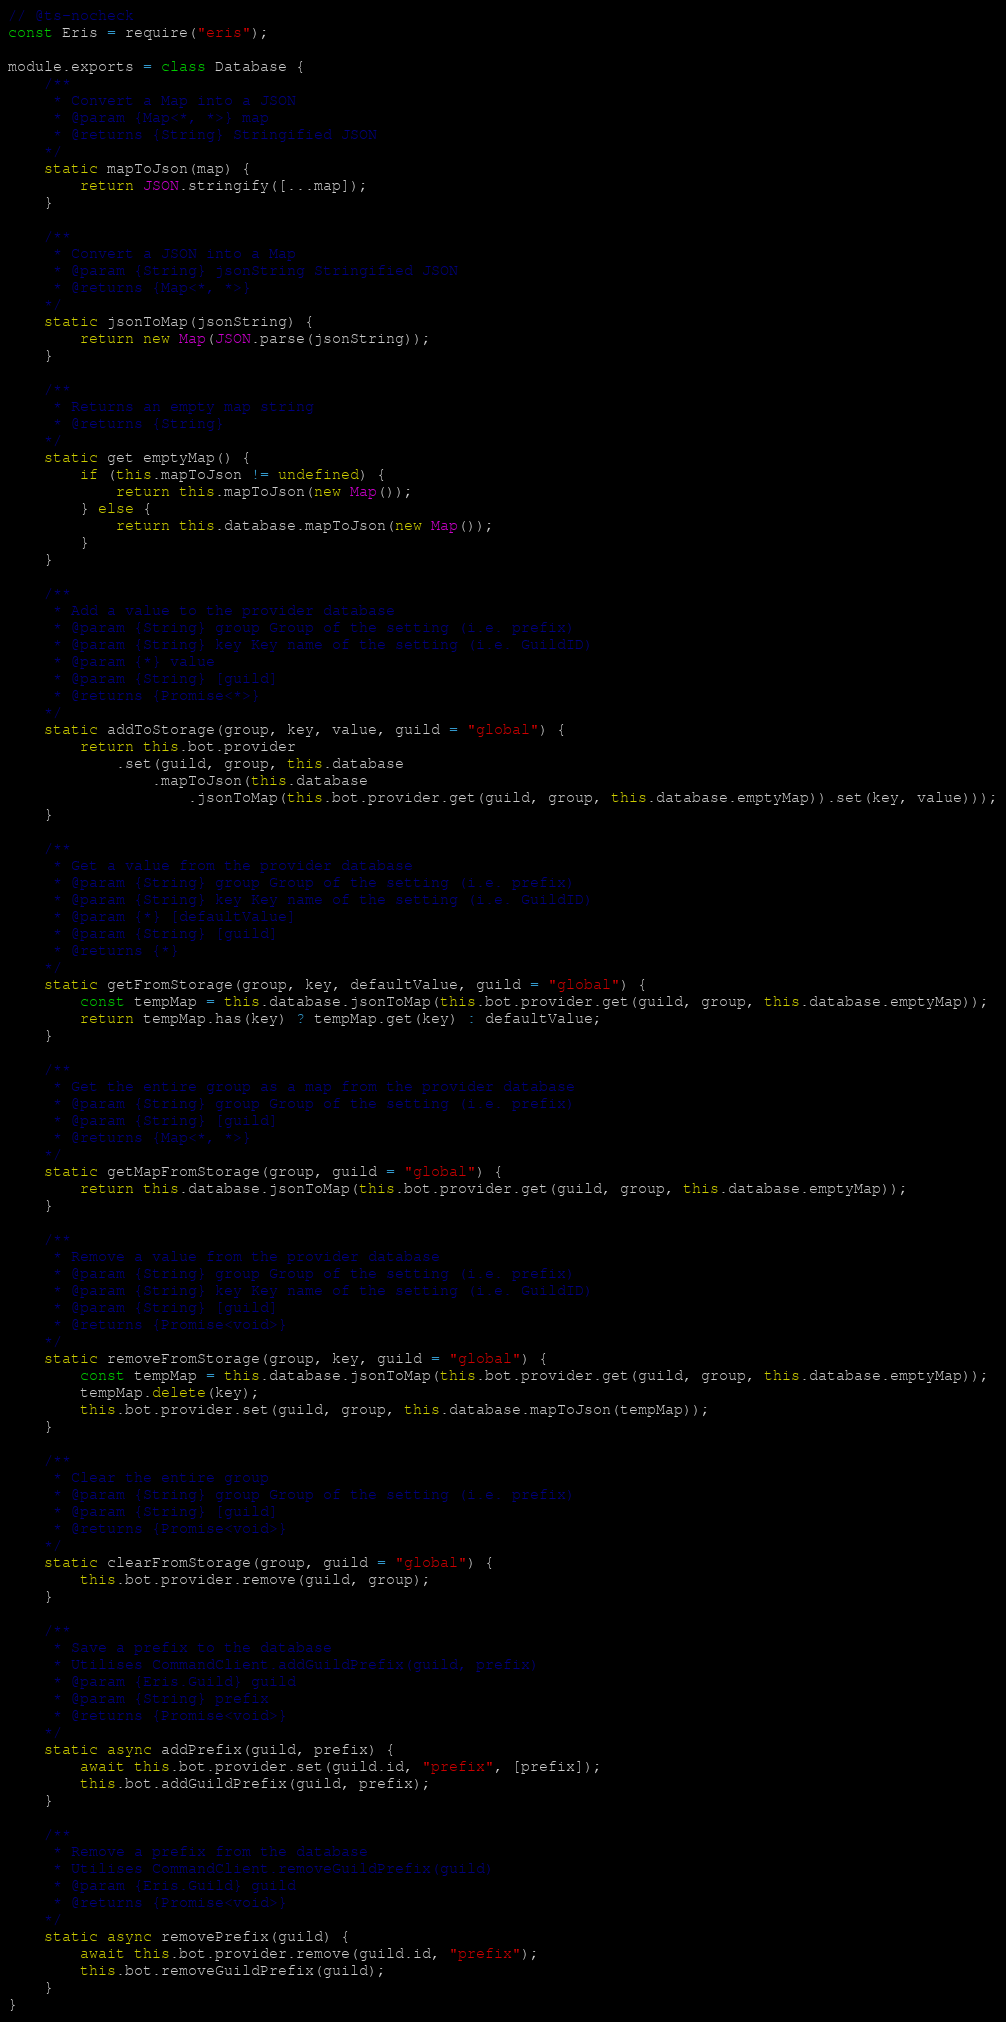Convert code to text. <code><loc_0><loc_0><loc_500><loc_500><_JavaScript_>// @ts-nocheck
const Eris = require("eris");

module.exports = class Database {
    /**
     * Convert a Map into a JSON
     * @param {Map<*, *>} map 
     * @returns {String} Stringified JSON
    */
    static mapToJson(map) {
        return JSON.stringify([...map]);
    }

    /**
     * Convert a JSON into a Map
     * @param {String} jsonString Stringified JSON
     * @returns {Map<*, *>}
    */
    static jsonToMap(jsonString) {
        return new Map(JSON.parse(jsonString));
    }

    /**
     * Returns an empty map string
     * @returns {String}
    */
    static get emptyMap() {
        if (this.mapToJson != undefined) {
            return this.mapToJson(new Map());
        } else {
            return this.database.mapToJson(new Map());
        }
    }

    /**
     * Add a value to the provider database
     * @param {String} group Group of the setting (i.e. prefix)
     * @param {String} key Key name of the setting (i.e. GuildID)
     * @param {*} value
     * @param {String} [guild]
     * @returns {Promise<*>} 
    */
    static addToStorage(group, key, value, guild = "global") {
        return this.bot.provider
            .set(guild, group, this.database
                .mapToJson(this.database
                    .jsonToMap(this.bot.provider.get(guild, group, this.database.emptyMap)).set(key, value)));
    }

    /**
     * Get a value from the provider database
     * @param {String} group Group of the setting (i.e. prefix)
     * @param {String} key Key name of the setting (i.e. GuildID)
     * @param {*} [defaultValue]
     * @param {String} [guild]
     * @returns {*}
    */
    static getFromStorage(group, key, defaultValue, guild = "global") {
        const tempMap = this.database.jsonToMap(this.bot.provider.get(guild, group, this.database.emptyMap));
        return tempMap.has(key) ? tempMap.get(key) : defaultValue;
    }

    /**
     * Get the entire group as a map from the provider database
     * @param {String} group Group of the setting (i.e. prefix)
     * @param {String} [guild]
     * @returns {Map<*, *>}
    */
    static getMapFromStorage(group, guild = "global") {
        return this.database.jsonToMap(this.bot.provider.get(guild, group, this.database.emptyMap));
    }

    /**
     * Remove a value from the provider database
     * @param {String} group Group of the setting (i.e. prefix)
     * @param {String} key Key name of the setting (i.e. GuildID)
     * @param {String} [guild]
     * @returns {Promise<void>}
    */
    static removeFromStorage(group, key, guild = "global") {
        const tempMap = this.database.jsonToMap(this.bot.provider.get(guild, group, this.database.emptyMap));
        tempMap.delete(key);
        this.bot.provider.set(guild, group, this.database.mapToJson(tempMap));
    }

    /**
     * Clear the entire group
     * @param {String} group Group of the setting (i.e. prefix)
     * @param {String} [guild]
     * @returns {Promise<void>}
    */
    static clearFromStorage(group, guild = "global") {
        this.bot.provider.remove(guild, group);
    }

    /**
     * Save a prefix to the database
     * Utilises CommandClient.addGuildPrefix(guild, prefix)
     * @param {Eris.Guild} guild 
     * @param {String} prefix 
     * @returns {Promise<void>}
    */
    static async addPrefix(guild, prefix) {
        await this.bot.provider.set(guild.id, "prefix", [prefix]);
        this.bot.addGuildPrefix(guild, prefix);
    }

    /**
     * Remove a prefix from the database
     * Utilises CommandClient.removeGuildPrefix(guild)
     * @param {Eris.Guild} guild 
     * @returns {Promise<void>}
    */
    static async removePrefix(guild) {
        await this.bot.provider.remove(guild.id, "prefix");
        this.bot.removeGuildPrefix(guild);
    }
}</code> 